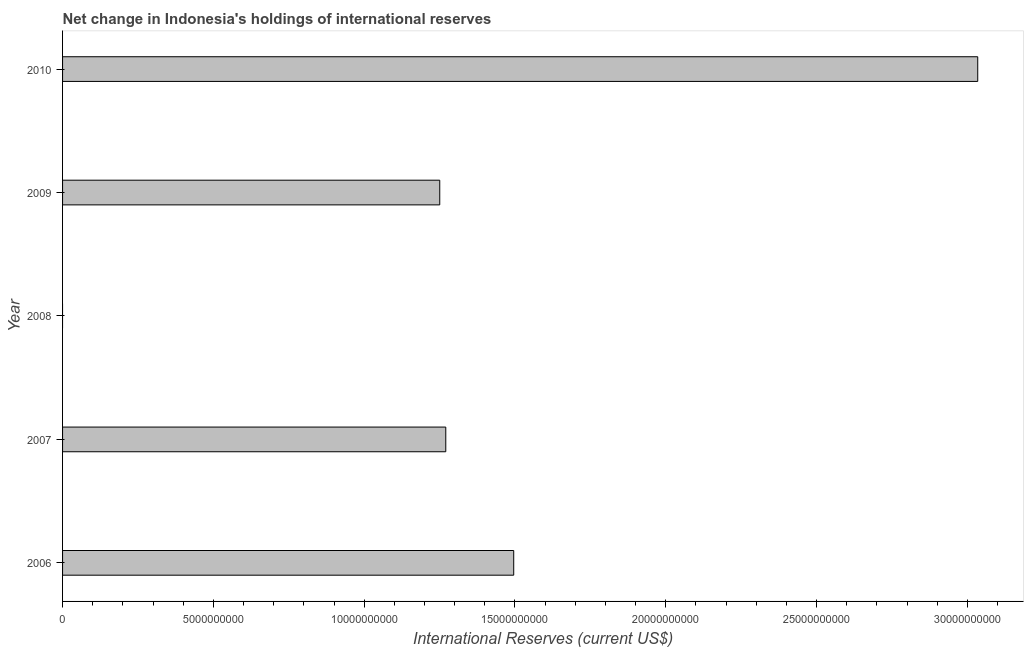What is the title of the graph?
Your response must be concise. Net change in Indonesia's holdings of international reserves. What is the label or title of the X-axis?
Your answer should be very brief. International Reserves (current US$). What is the label or title of the Y-axis?
Offer a very short reply. Year. What is the reserves and related items in 2009?
Keep it short and to the point. 1.25e+1. Across all years, what is the maximum reserves and related items?
Make the answer very short. 3.03e+1. Across all years, what is the minimum reserves and related items?
Provide a short and direct response. 0. In which year was the reserves and related items maximum?
Provide a short and direct response. 2010. What is the sum of the reserves and related items?
Give a very brief answer. 7.05e+1. What is the difference between the reserves and related items in 2009 and 2010?
Make the answer very short. -1.78e+1. What is the average reserves and related items per year?
Your answer should be compact. 1.41e+1. What is the median reserves and related items?
Your answer should be compact. 1.27e+1. In how many years, is the reserves and related items greater than 3000000000 US$?
Offer a very short reply. 4. What is the ratio of the reserves and related items in 2009 to that in 2010?
Offer a terse response. 0.41. Is the reserves and related items in 2006 less than that in 2007?
Ensure brevity in your answer.  No. Is the difference between the reserves and related items in 2006 and 2007 greater than the difference between any two years?
Your answer should be compact. No. What is the difference between the highest and the second highest reserves and related items?
Offer a very short reply. 1.54e+1. What is the difference between the highest and the lowest reserves and related items?
Provide a succinct answer. 3.03e+1. In how many years, is the reserves and related items greater than the average reserves and related items taken over all years?
Offer a terse response. 2. How many bars are there?
Ensure brevity in your answer.  4. Are all the bars in the graph horizontal?
Keep it short and to the point. Yes. What is the difference between two consecutive major ticks on the X-axis?
Your response must be concise. 5.00e+09. What is the International Reserves (current US$) of 2006?
Make the answer very short. 1.50e+1. What is the International Reserves (current US$) in 2007?
Your response must be concise. 1.27e+1. What is the International Reserves (current US$) in 2008?
Your answer should be very brief. 0. What is the International Reserves (current US$) of 2009?
Offer a terse response. 1.25e+1. What is the International Reserves (current US$) of 2010?
Ensure brevity in your answer.  3.03e+1. What is the difference between the International Reserves (current US$) in 2006 and 2007?
Your answer should be compact. 2.25e+09. What is the difference between the International Reserves (current US$) in 2006 and 2009?
Ensure brevity in your answer.  2.45e+09. What is the difference between the International Reserves (current US$) in 2006 and 2010?
Give a very brief answer. -1.54e+1. What is the difference between the International Reserves (current US$) in 2007 and 2009?
Keep it short and to the point. 2.00e+08. What is the difference between the International Reserves (current US$) in 2007 and 2010?
Provide a short and direct response. -1.76e+1. What is the difference between the International Reserves (current US$) in 2009 and 2010?
Your response must be concise. -1.78e+1. What is the ratio of the International Reserves (current US$) in 2006 to that in 2007?
Your response must be concise. 1.18. What is the ratio of the International Reserves (current US$) in 2006 to that in 2009?
Keep it short and to the point. 1.2. What is the ratio of the International Reserves (current US$) in 2006 to that in 2010?
Your response must be concise. 0.49. What is the ratio of the International Reserves (current US$) in 2007 to that in 2010?
Give a very brief answer. 0.42. What is the ratio of the International Reserves (current US$) in 2009 to that in 2010?
Your response must be concise. 0.41. 